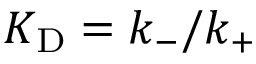Convert formula to latex. <formula><loc_0><loc_0><loc_500><loc_500>{ K _ { D } } = k _ { - } / k _ { + }</formula> 